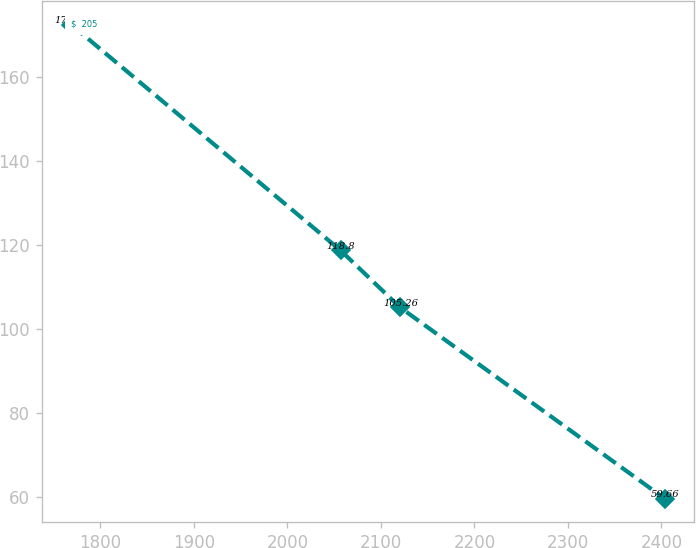Convert chart. <chart><loc_0><loc_0><loc_500><loc_500><line_chart><ecel><fcel>$  205<nl><fcel>1768.65<fcel>172.59<nl><fcel>2056.76<fcel>118.8<nl><fcel>2120.25<fcel>105.26<nl><fcel>2403.51<fcel>59.66<nl></chart> 